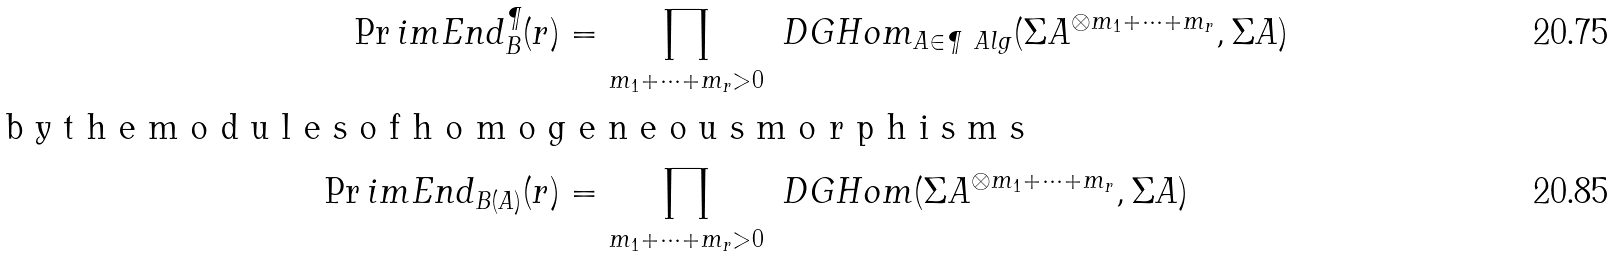Convert formula to latex. <formula><loc_0><loc_0><loc_500><loc_500>\Pr i m E n d _ { B } ^ { \P } ( r ) & = \prod _ { m _ { 1 } + \dots + m _ { r } > 0 } \ D G H o m _ { A \in \P \ A l g } ( \Sigma A ^ { \otimes m _ { 1 } + \dots + m _ { r } } , \Sigma A ) \\ \intertext { b y t h e m o d u l e s o f h o m o g e n e o u s m o r p h i s m s } \Pr i m E n d _ { B ( A ) } ( r ) & = \prod _ { m _ { 1 } + \dots + m _ { r } > 0 } \ D G H o m ( \Sigma A ^ { \otimes m _ { 1 } + \dots + m _ { r } } , \Sigma A )</formula> 